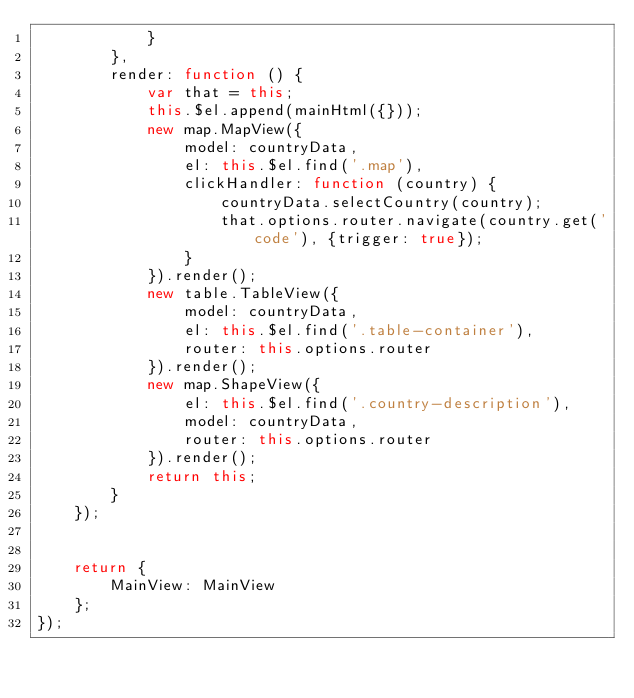Convert code to text. <code><loc_0><loc_0><loc_500><loc_500><_JavaScript_>            }
        },
        render: function () {
            var that = this;
            this.$el.append(mainHtml({}));
            new map.MapView({
                model: countryData,
                el: this.$el.find('.map'),
                clickHandler: function (country) {
                    countryData.selectCountry(country);
                    that.options.router.navigate(country.get('code'), {trigger: true});
                }
            }).render();
            new table.TableView({
                model: countryData,
                el: this.$el.find('.table-container'),
                router: this.options.router
            }).render();
            new map.ShapeView({
                el: this.$el.find('.country-description'),
                model: countryData,
                router: this.options.router
            }).render();
            return this;
        }
    });


    return {
        MainView: MainView
    };
});</code> 